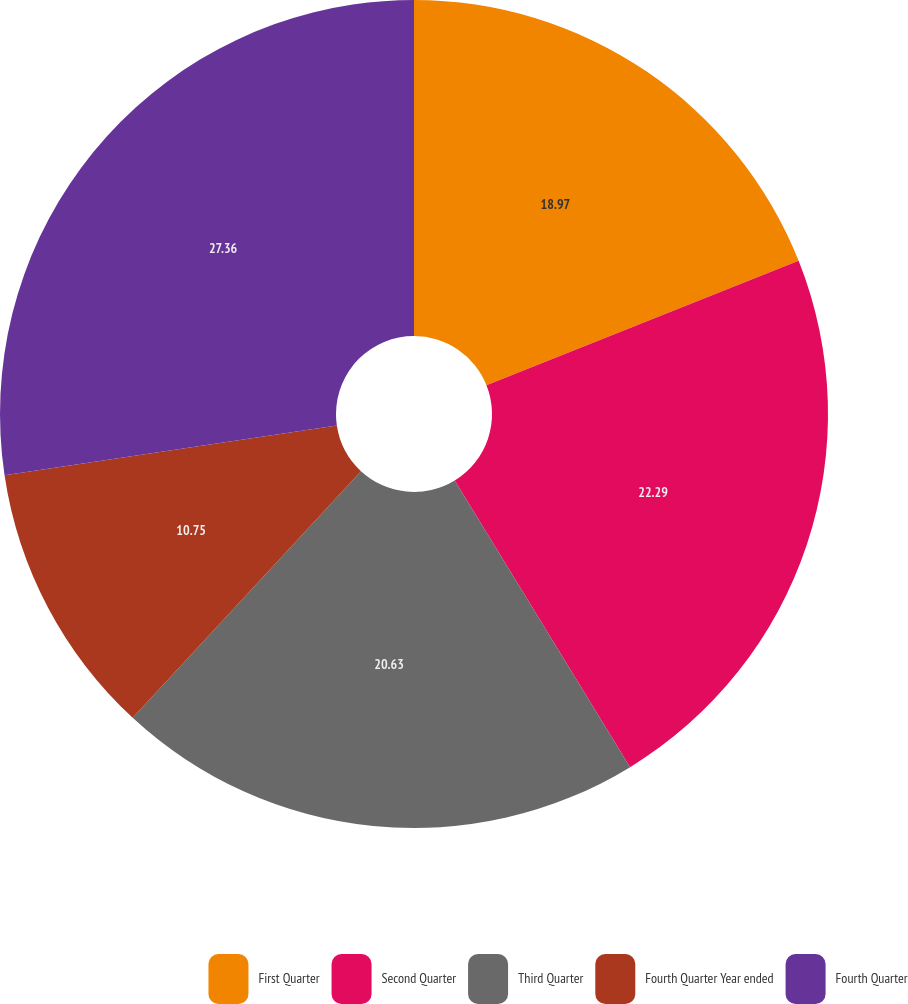Convert chart. <chart><loc_0><loc_0><loc_500><loc_500><pie_chart><fcel>First Quarter<fcel>Second Quarter<fcel>Third Quarter<fcel>Fourth Quarter Year ended<fcel>Fourth Quarter<nl><fcel>18.97%<fcel>22.29%<fcel>20.63%<fcel>10.75%<fcel>27.36%<nl></chart> 